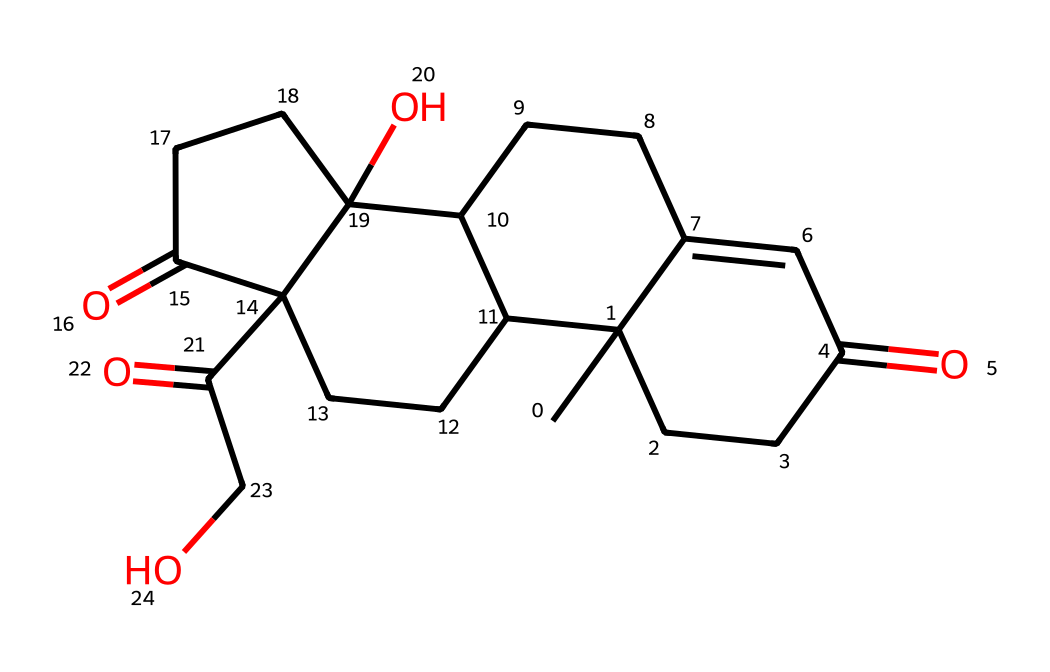What is the name of this compound? The SMILES representation corresponds to cortisol, which is recognized as a glucocorticoid hormone.
Answer: cortisol How many carbon atoms are present in this compound? By analyzing the SMILES notation, I count a total of 21 carbon atoms within the structure.
Answer: 21 Does this compound contain any functional groups? The structure includes ketone groups represented by carbonyl functions, specifically C=O, which are part of the steroid framework.
Answer: ketones Is this compound chiral? The presence of stereocenters in the structure indicates the compound has chirality, which can be confirmed by examining its stereocenters.
Answer: yes What is the stereocenter configuration in this compound? The stereocenters can typically have R/S configuration based on the arrangement of priority groups around carbon atoms; the exact configuration requires 3D modeling.
Answer: unspecified How many rings are present in the molecular structure? By observing the structure within the SMILES, I find there are four interconnected ring structures that make up the core of cortisol.
Answer: 4 What role does cortisol play in the human body? Cortisol functions primarily as a stress hormone by regulating metabolism and the immune response, particularly in stressful situations.
Answer: stress hormone 